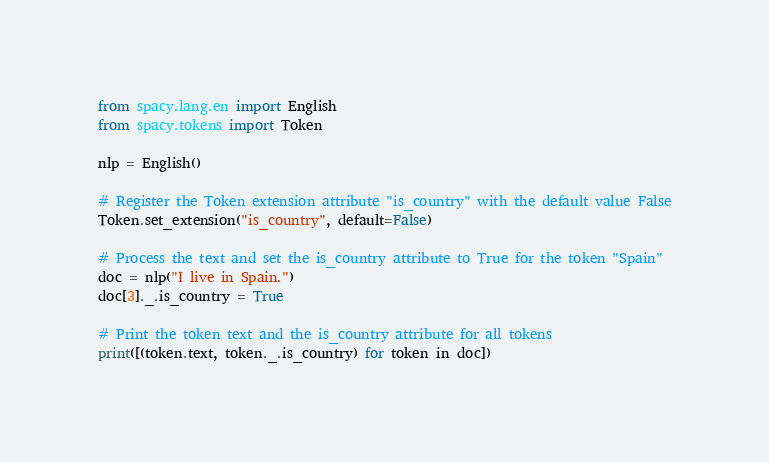<code> <loc_0><loc_0><loc_500><loc_500><_Python_>from spacy.lang.en import English
from spacy.tokens import Token

nlp = English()

# Register the Token extension attribute "is_country" with the default value False
Token.set_extension("is_country", default=False)

# Process the text and set the is_country attribute to True for the token "Spain"
doc = nlp("I live in Spain.")
doc[3]._.is_country = True

# Print the token text and the is_country attribute for all tokens
print([(token.text, token._.is_country) for token in doc])
</code> 